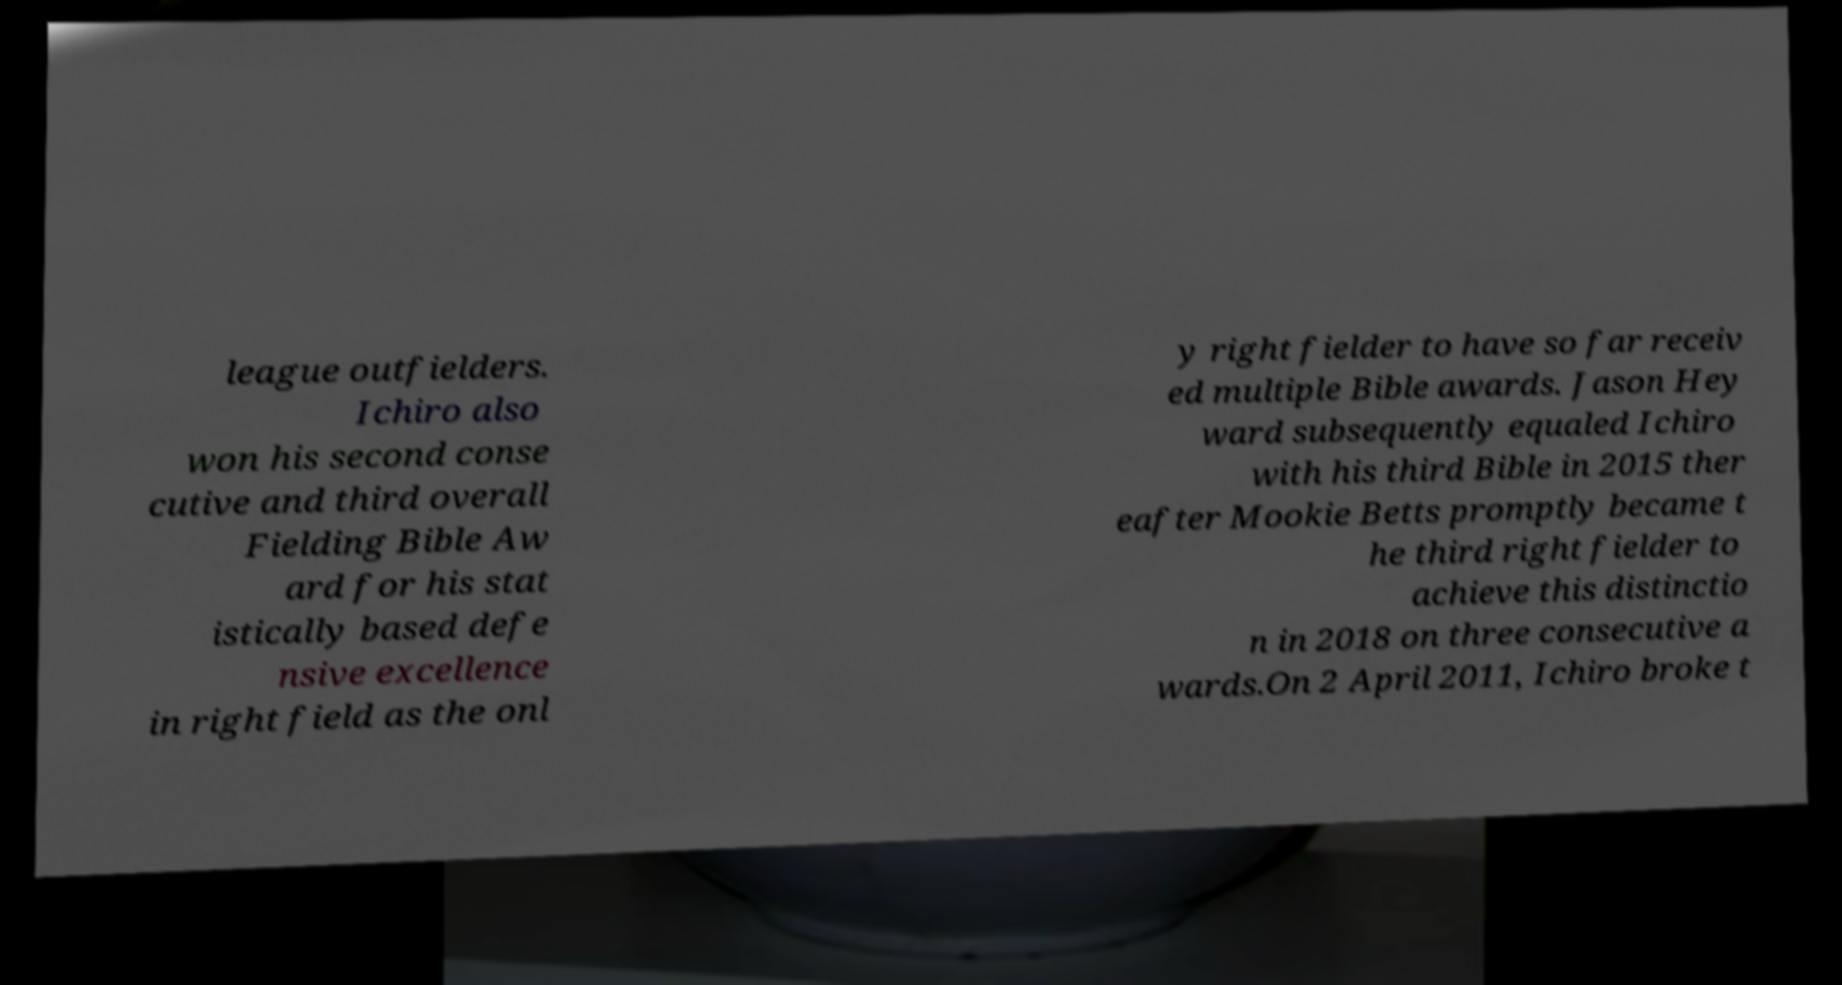Can you read and provide the text displayed in the image?This photo seems to have some interesting text. Can you extract and type it out for me? league outfielders. Ichiro also won his second conse cutive and third overall Fielding Bible Aw ard for his stat istically based defe nsive excellence in right field as the onl y right fielder to have so far receiv ed multiple Bible awards. Jason Hey ward subsequently equaled Ichiro with his third Bible in 2015 ther eafter Mookie Betts promptly became t he third right fielder to achieve this distinctio n in 2018 on three consecutive a wards.On 2 April 2011, Ichiro broke t 